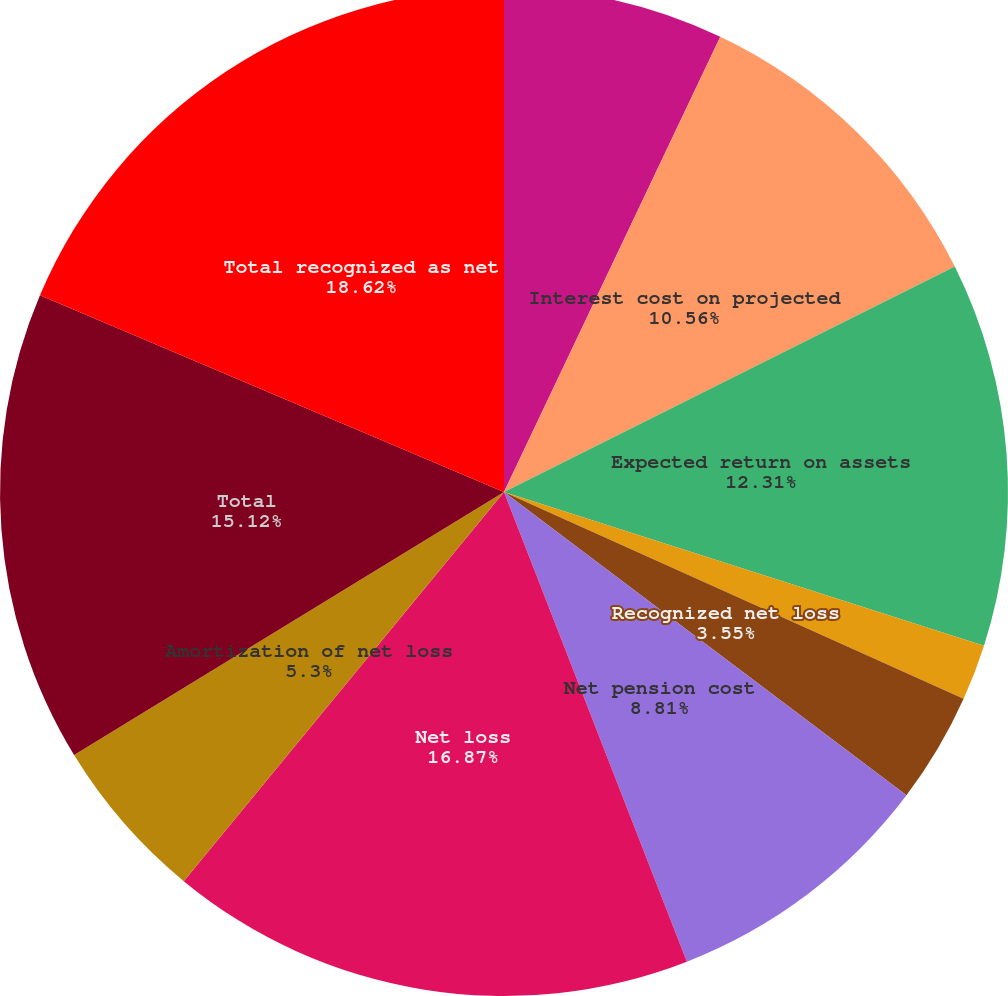Convert chart. <chart><loc_0><loc_0><loc_500><loc_500><pie_chart><fcel>Service cost - benefits earned<fcel>Interest cost on projected<fcel>Expected return on assets<fcel>Amortization of prior service<fcel>Recognized net loss<fcel>Net pension cost<fcel>Net loss<fcel>Amortization of net loss<fcel>Total<fcel>Total recognized as net<nl><fcel>7.06%<fcel>10.56%<fcel>12.31%<fcel>1.8%<fcel>3.55%<fcel>8.81%<fcel>16.87%<fcel>5.3%<fcel>15.12%<fcel>18.62%<nl></chart> 